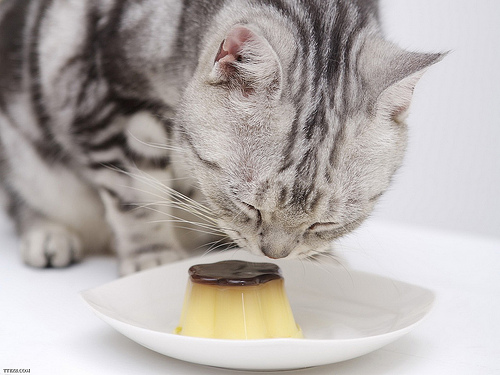Please provide the bounding box coordinate of the region this sentence describes: two cat ears. The pair of ears on the cat are prominently displayed atop its head, with coordinates capturing both ears at [0.42, 0.16, 0.9, 0.36]. 